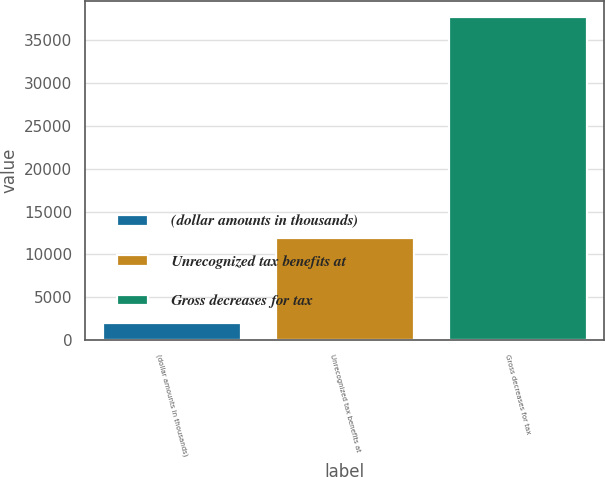Convert chart. <chart><loc_0><loc_0><loc_500><loc_500><bar_chart><fcel>(dollar amounts in thousands)<fcel>Unrecognized tax benefits at<fcel>Gross decreases for tax<nl><fcel>2011<fcel>11896<fcel>37610<nl></chart> 